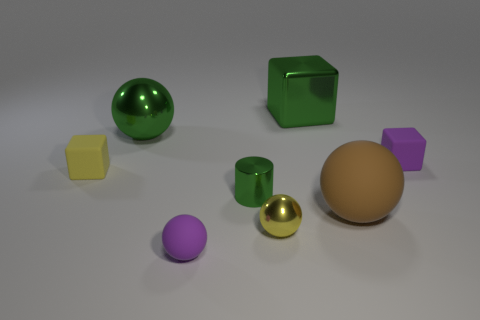What number of things are green objects or purple cubes? In the image, there are two objects that are green - one sphere and one cube. Additionally, there is one purple cube. So, there are a total of three objects that are either green or purple cubes. 